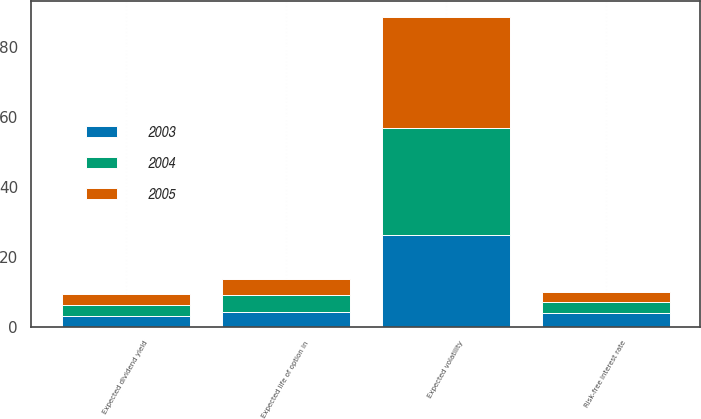Convert chart. <chart><loc_0><loc_0><loc_500><loc_500><stacked_bar_chart><ecel><fcel>Risk-free interest rate<fcel>Expected life of option in<fcel>Expected dividend yield<fcel>Expected volatility<nl><fcel>2003<fcel>3.8<fcel>4.3<fcel>3.1<fcel>26.3<nl><fcel>2004<fcel>3.2<fcel>4.6<fcel>3.2<fcel>30.5<nl><fcel>2005<fcel>3<fcel>4.8<fcel>3<fcel>32<nl></chart> 